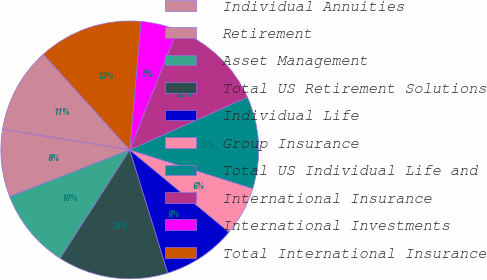Convert chart. <chart><loc_0><loc_0><loc_500><loc_500><pie_chart><fcel>Individual Annuities<fcel>Retirement<fcel>Asset Management<fcel>Total US Retirement Solutions<fcel>Individual Life<fcel>Group Insurance<fcel>Total US Individual Life and<fcel>International Insurance<fcel>International Investments<fcel>Total International Insurance<nl><fcel>10.77%<fcel>8.46%<fcel>10.0%<fcel>13.84%<fcel>9.23%<fcel>6.16%<fcel>11.54%<fcel>12.3%<fcel>4.63%<fcel>13.07%<nl></chart> 